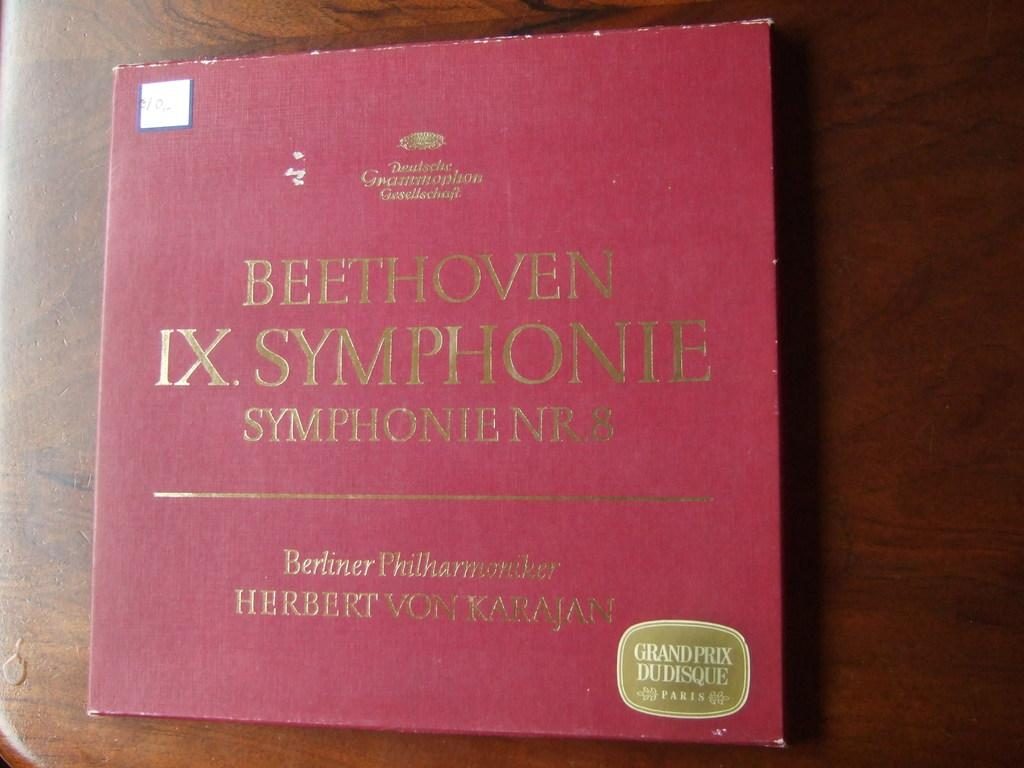<image>
Give a short and clear explanation of the subsequent image. A record of Beethoven's IX. Symphonie NR.8 sitting on a wood surface 